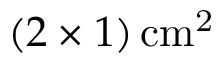Convert formula to latex. <formula><loc_0><loc_0><loc_500><loc_500>( 2 \times 1 ) \, c m ^ { 2 }</formula> 